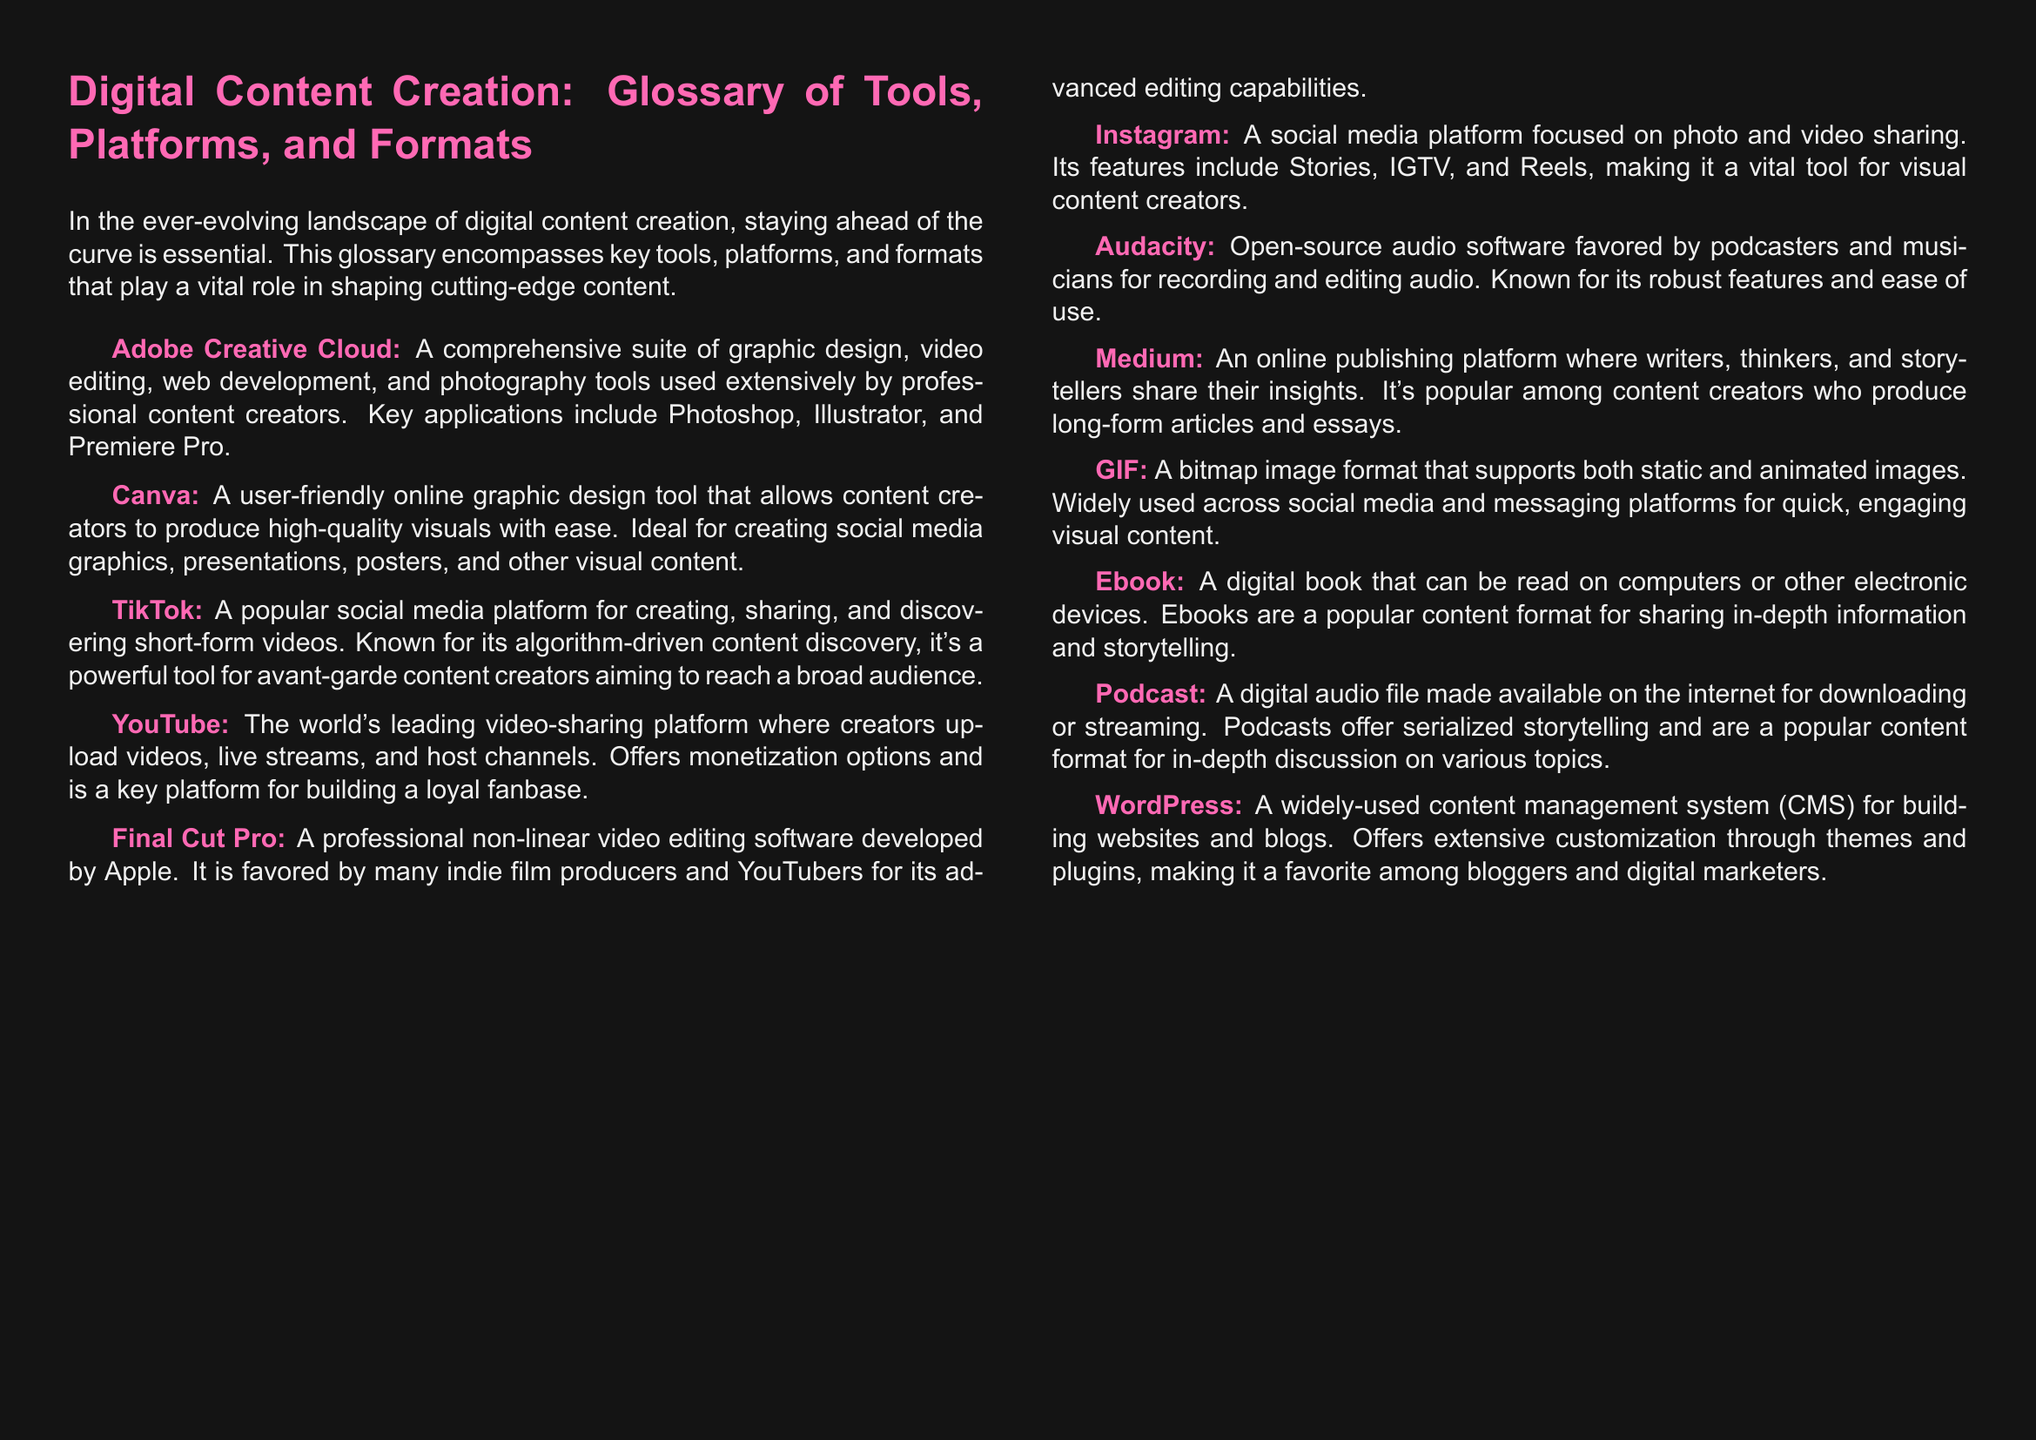What is the name of the software favored by many indie film producers? The document lists Final Cut Pro as the software favored by many indie film producers for its advanced editing capabilities.
Answer: Final Cut Pro What platform allows creators to produce high-quality visuals easily? The document states that Canva is a user-friendly online graphic design tool that allows content creators to produce high-quality visuals with ease.
Answer: Canva What is the primary format discussed that supports animated images? The document mentions GIF as a bitmap image format that supports both static and animated images, widely used across social media.
Answer: GIF Which platform is recognized as the world's leading video-sharing platform? According to the document, YouTube is identified as the world's leading video-sharing platform.
Answer: YouTube What type of content does Medium primarily focus on? The document indicates that Medium is an online publishing platform where writers share their insights, popular for long-form articles and essays.
Answer: Long-form articles Which audio software is favored by podcasters for recording? The document lists Audacity as the open-source audio software favored by podcasters for recording and editing audio.
Answer: Audacity What is a popular serial content format discussed in the document? The document describes podcasts as a digital audio file made available for downloading or streaming, offering serialized storytelling.
Answer: Podcast How is WordPress classified in the document? The document states that WordPress is a widely-used content management system for building websites and blogs.
Answer: Content management system What is the primary focus of the TikTok platform? The document describes TikTok as a platform for creating, sharing, and discovering short-form videos.
Answer: Short-form videos 